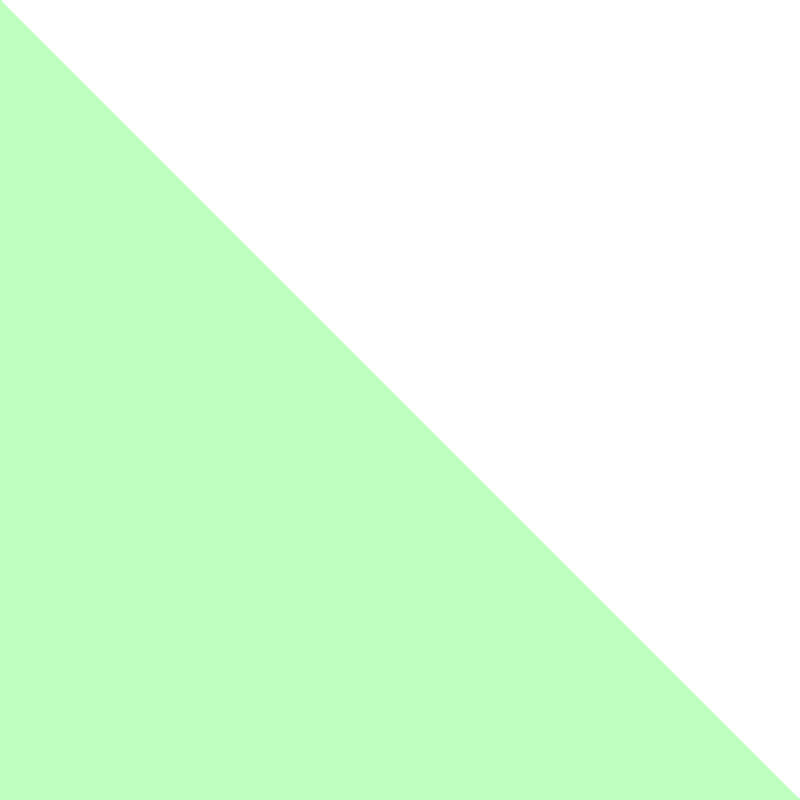In the ternary diagram above, two glaze compositions (P1 and P2) are plotted. P1 (red dot) represents a glaze with 60% Feldspar, 20% Silica, and 20% Kaolin. If P2 (blue dot) has the same amount of Kaolin as P1, what are the percentages of Feldspar and Silica in P2? To solve this problem, we need to follow these steps:

1. Recognize that in a ternary diagram, the sum of all three components always equals 100%.

2. Identify that P2 has the same amount of Kaolin as P1, which is 20%.

3. Observe the position of P2 relative to the Feldspar-Silica axis:
   - It's closer to the Silica corner than P1
   - It's about halfway between the Feldspar and Silica corners

4. Calculate the remaining 80% (100% - 20% Kaolin) split between Feldspar and Silica:
   - Since P2 is about halfway between Feldspar and Silica, we can estimate that it's close to a 50-50 split of the remaining 80%.

5. Calculate the approximate percentages:
   - Feldspar: 80% × 0.5 = 40%
   - Silica: 80% × 0.5 = 40%

6. Verify: 40% (Feldspar) + 40% (Silica) + 20% (Kaolin) = 100%

Therefore, P2 consists of approximately 30% Feldspar, 50% Silica, and 20% Kaolin.
Answer: 30% Feldspar, 50% Silica 